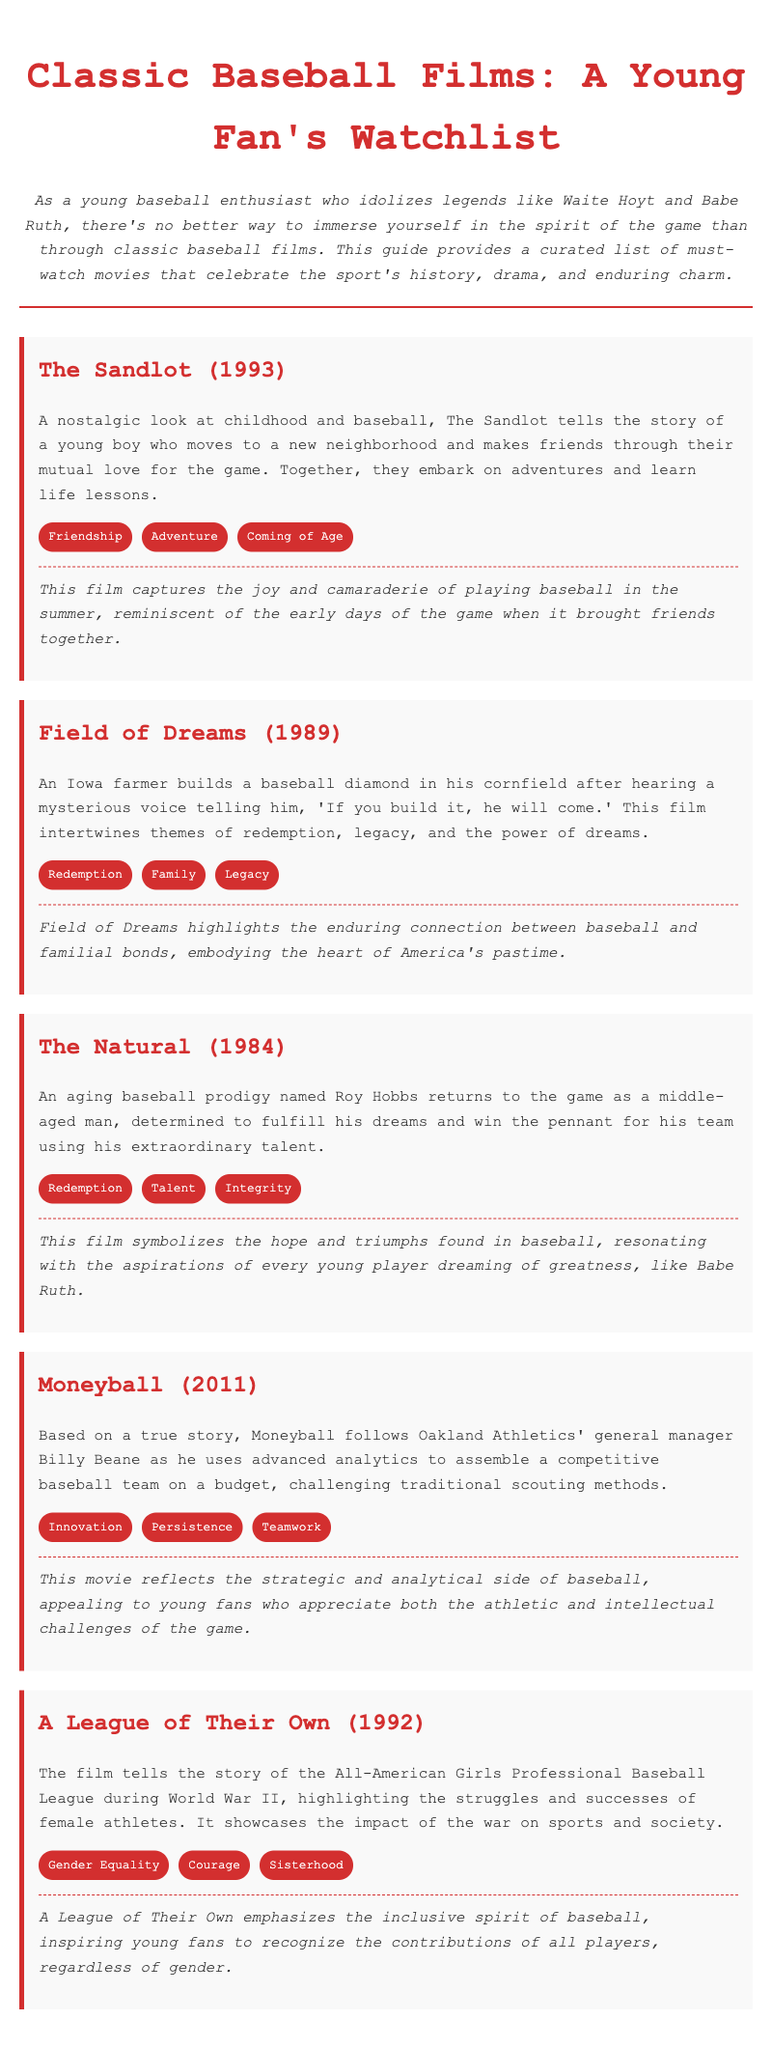What is the title of the first movie listed? The first movie listed is clearly stated in the document as "The Sandlot (1993)."
Answer: The Sandlot (1993) What year was "Field of Dreams" released? The release date of "Field of Dreams" is explicitly mentioned in the document.
Answer: 1989 Which movie features a middle-aged baseball prodigy? The film that features an aging baseball prodigy is "The Natural," as described in the document.
Answer: The Natural What theme is associated with "A League of Their Own"? The themes for "A League of Their Own" include Gender Equality, Courage, and Sisterhood, as specified in the movie's section.
Answer: Gender Equality What is one keyword that describes the movie "Moneyball"? The document mentions several keywords, but "Innovation" is highlighted as a central theme of "Moneyball."
Answer: Innovation How does "The Sandlot" resonate with the spirit of baseball? The document states that "The Sandlot" captures the joy and camaraderie of playing baseball in the summer.
Answer: Joy and camaraderie What common theme do both "The Natural" and "Field of Dreams" share? Both films share the theme of "Redemption," as listed in their respective thematic sections.
Answer: Redemption In which movie is baseball portrayed as a female sport during WWII? The document explicitly refers to "A League of Their Own" in relation to female athletes during World War II.
Answer: A League of Their Own 